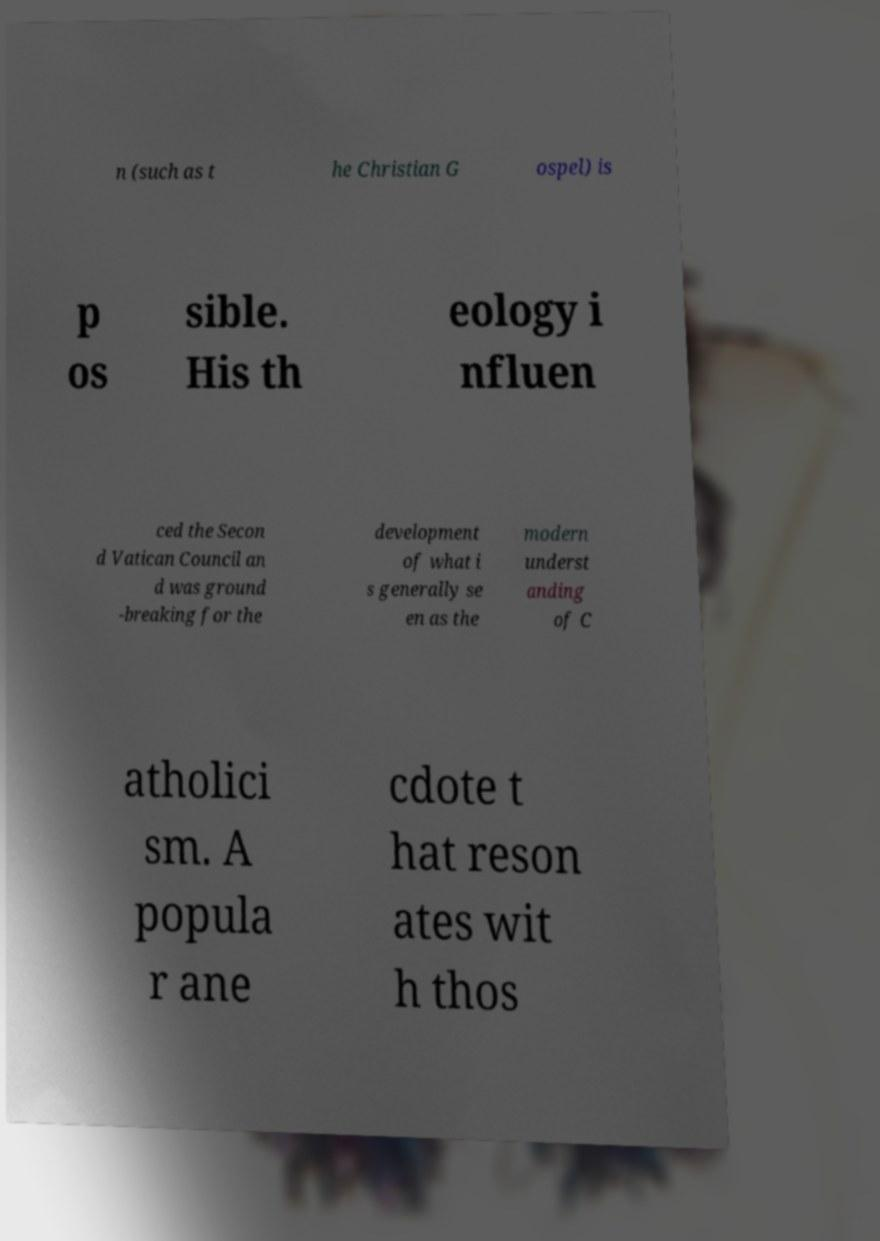Can you read and provide the text displayed in the image?This photo seems to have some interesting text. Can you extract and type it out for me? n (such as t he Christian G ospel) is p os sible. His th eology i nfluen ced the Secon d Vatican Council an d was ground -breaking for the development of what i s generally se en as the modern underst anding of C atholici sm. A popula r ane cdote t hat reson ates wit h thos 